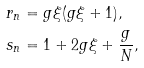Convert formula to latex. <formula><loc_0><loc_0><loc_500><loc_500>r _ { n } & = g \xi ( g \xi + 1 ) , \\ s _ { n } & = 1 + 2 g \xi + \frac { g } { N } ,</formula> 